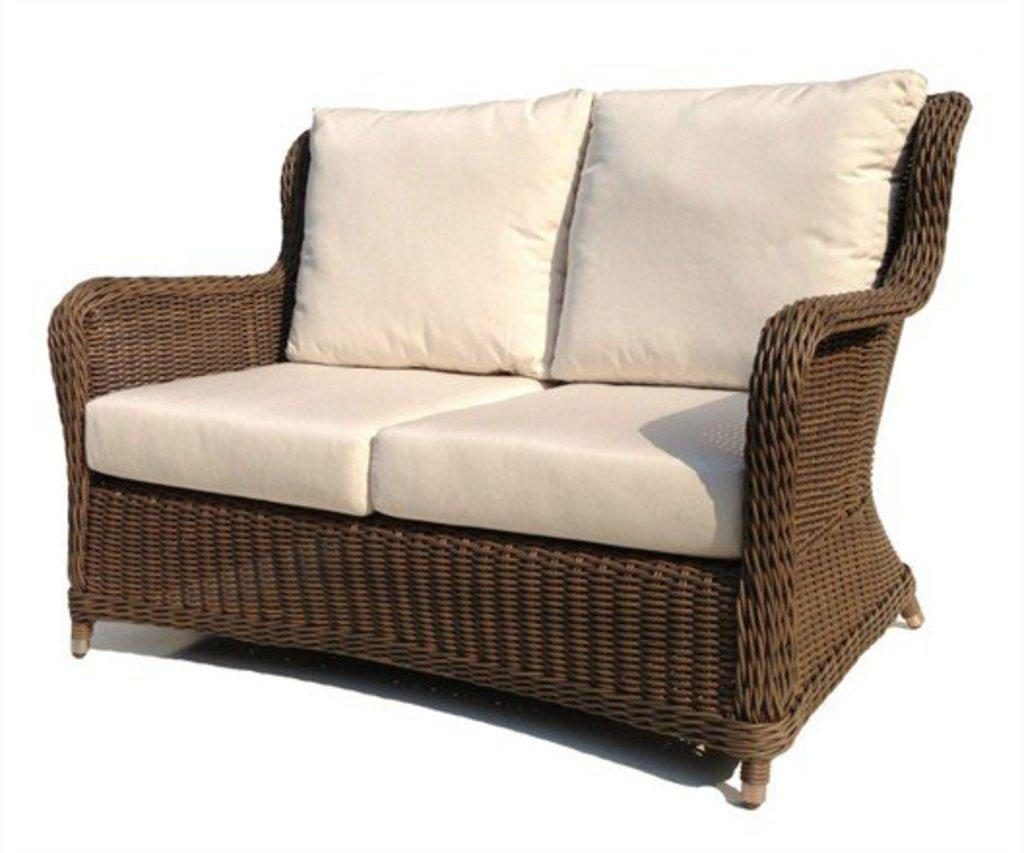What type of furniture is present in the image? There is a sofa set in the image. Can you tell me how many dogs are sitting on the sofa set in the image? There are no dogs present in the image; it only features a sofa set. What type of joke is being told by the people sitting on the sofa set in the image? There are no people or jokes present in the image; it only features a sofa set. 